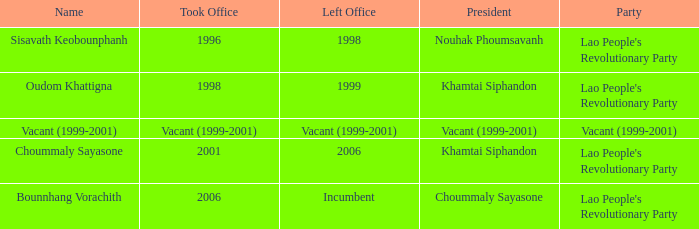What is Left Office, when Party is Vacant (1999-2001)? Vacant (1999-2001). 